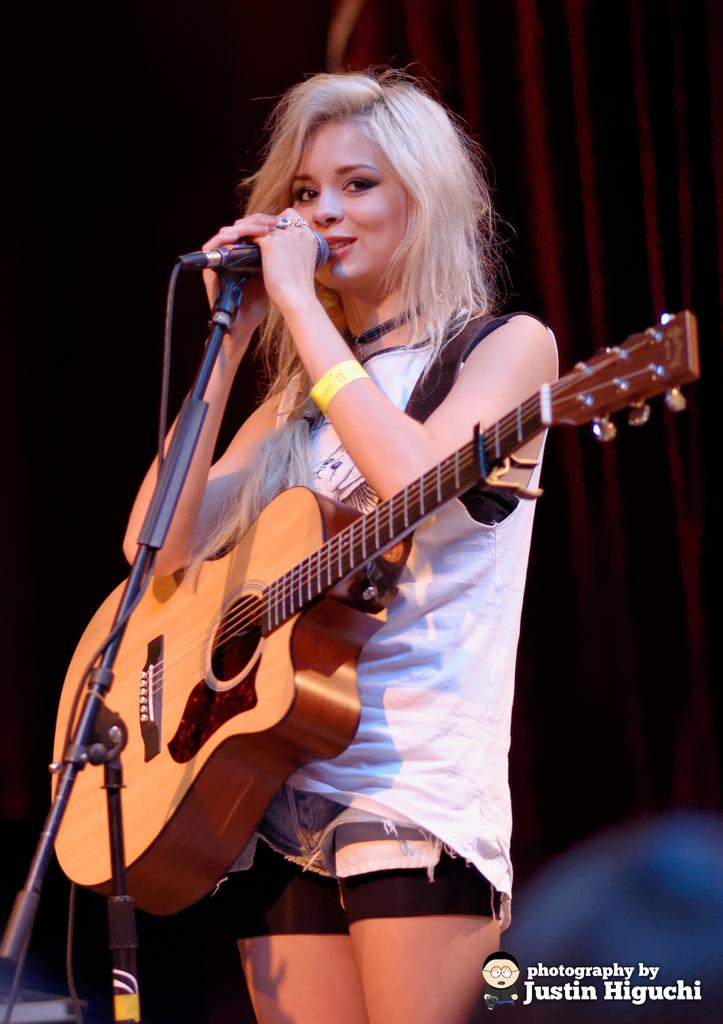Who is the main subject in the image? There is a woman in the image. What is the woman wearing? The woman is wearing a white dress. What is the woman holding in the image? The woman is holding a guitar. What is the woman doing in the image? The woman is singing. What object is present to amplify her voice? There is a microphone in the image. Can you see a flower in the woman's hair in the image? There is no flower visible in the woman's hair in the image. Is the woman using a brush to play the guitar in the image? There is no brush present in the image, and the woman is holding a guitar, not a brush. 